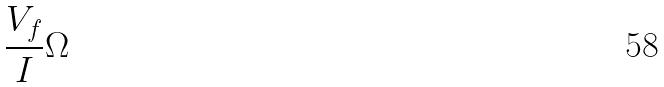<formula> <loc_0><loc_0><loc_500><loc_500>\frac { V _ { f } } { I } \Omega</formula> 